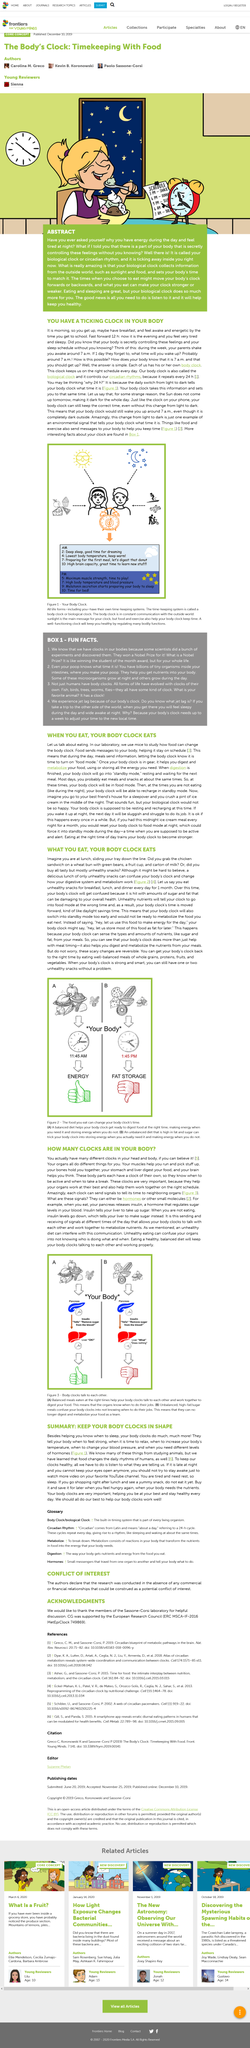Specify some key components in this picture. The body's circadian rhythm, also known as the body clock, is in a state of rest and readiness for the next meal. In the body, each clock sends signals to other organs through hormones and small molecules. Yes, the daily switch from light to dark can tell the body what time it is. Eating an unhealthy diet can confuse our body's circadian rhythms, leading to negative health consequences. The process of consuming a high-fat diet can lead to fat storage in the body. 